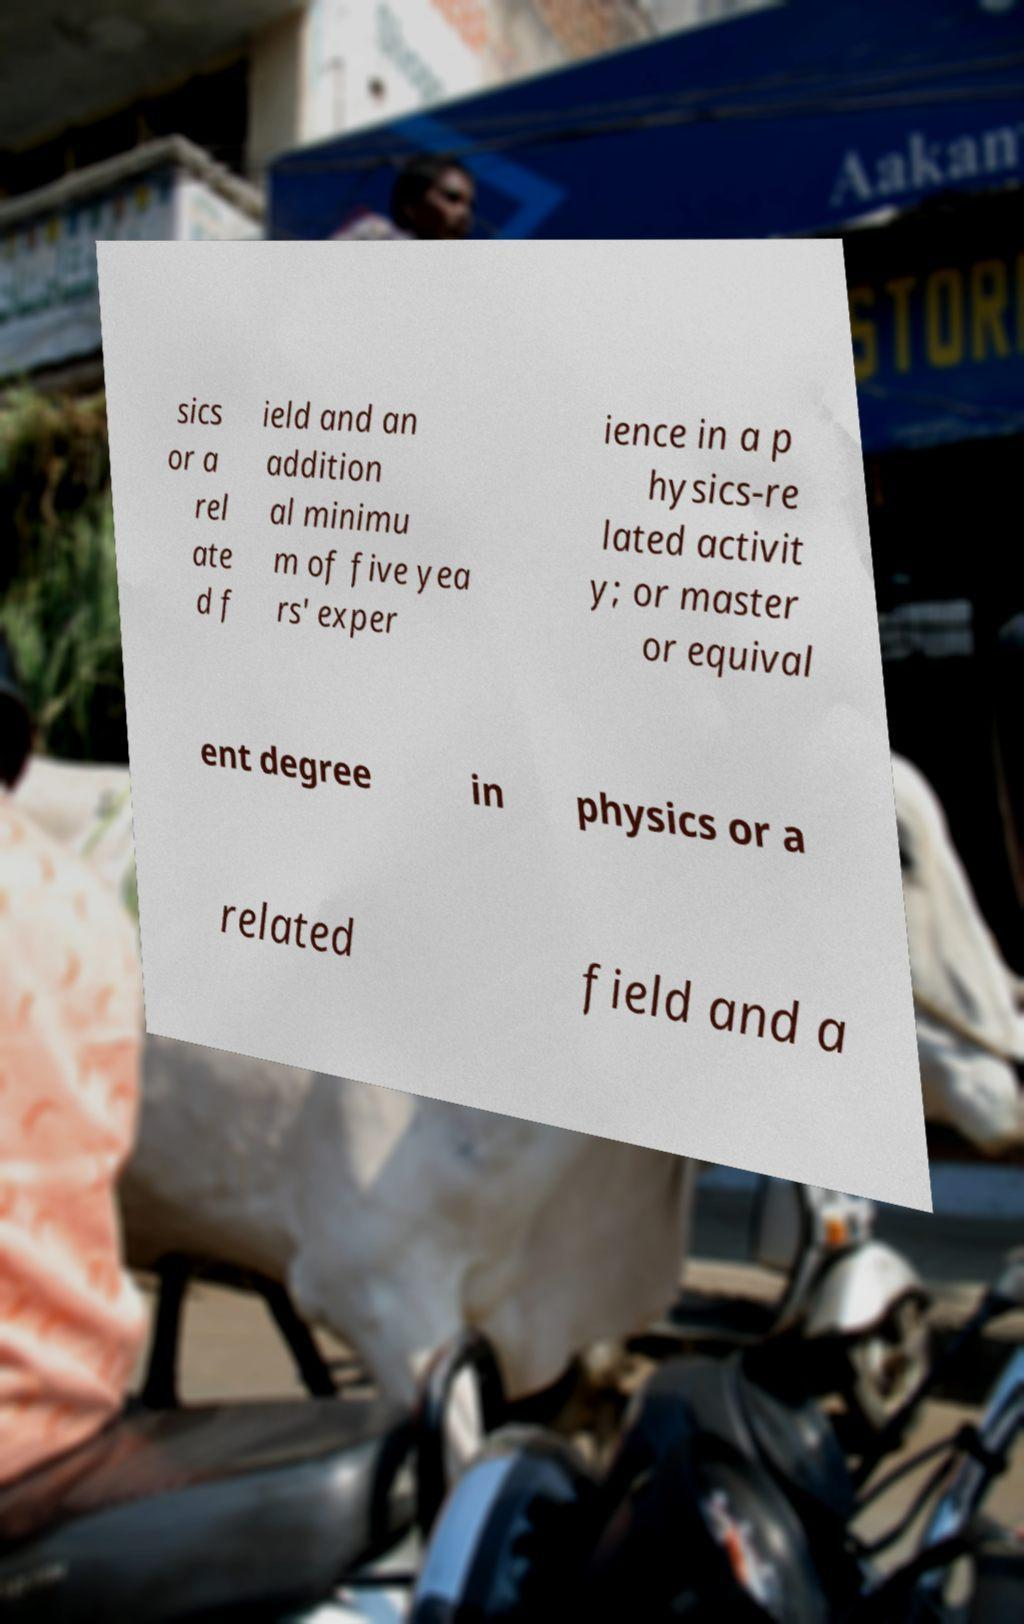Could you assist in decoding the text presented in this image and type it out clearly? sics or a rel ate d f ield and an addition al minimu m of five yea rs' exper ience in a p hysics-re lated activit y; or master or equival ent degree in physics or a related field and a 